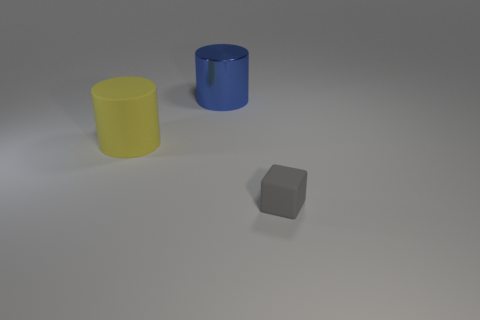What is the shape of the rubber thing that is to the right of the big cylinder that is behind the yellow matte thing?
Offer a very short reply. Cube. There is a thing behind the yellow rubber object; what shape is it?
Ensure brevity in your answer.  Cylinder. There is a thing that is on the right side of the big yellow cylinder and in front of the blue object; what shape is it?
Your response must be concise. Cube. What number of purple things are either shiny things or spheres?
Offer a very short reply. 0. There is a thing on the right side of the thing behind the big matte cylinder; what is its size?
Keep it short and to the point. Small. There is a blue cylinder that is the same size as the yellow rubber object; what is its material?
Ensure brevity in your answer.  Metal. What number of other things are the same size as the blue thing?
Offer a terse response. 1. How many blocks are purple rubber things or large metal things?
Your answer should be very brief. 0. Is there anything else that is made of the same material as the big blue thing?
Ensure brevity in your answer.  No. What material is the thing in front of the rubber thing behind the tiny gray rubber thing that is in front of the blue shiny object?
Offer a terse response. Rubber. 